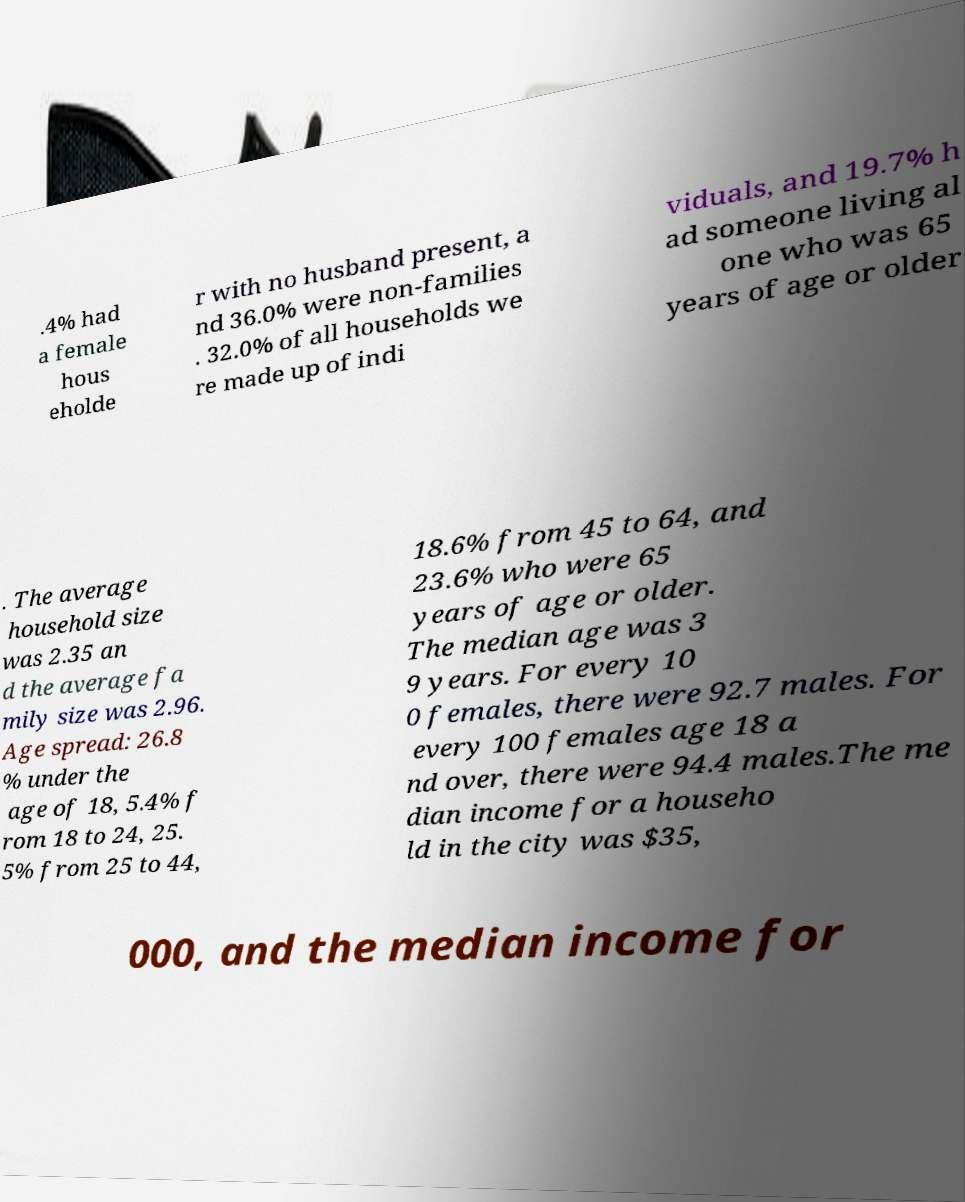What messages or text are displayed in this image? I need them in a readable, typed format. .4% had a female hous eholde r with no husband present, a nd 36.0% were non-families . 32.0% of all households we re made up of indi viduals, and 19.7% h ad someone living al one who was 65 years of age or older . The average household size was 2.35 an d the average fa mily size was 2.96. Age spread: 26.8 % under the age of 18, 5.4% f rom 18 to 24, 25. 5% from 25 to 44, 18.6% from 45 to 64, and 23.6% who were 65 years of age or older. The median age was 3 9 years. For every 10 0 females, there were 92.7 males. For every 100 females age 18 a nd over, there were 94.4 males.The me dian income for a househo ld in the city was $35, 000, and the median income for 